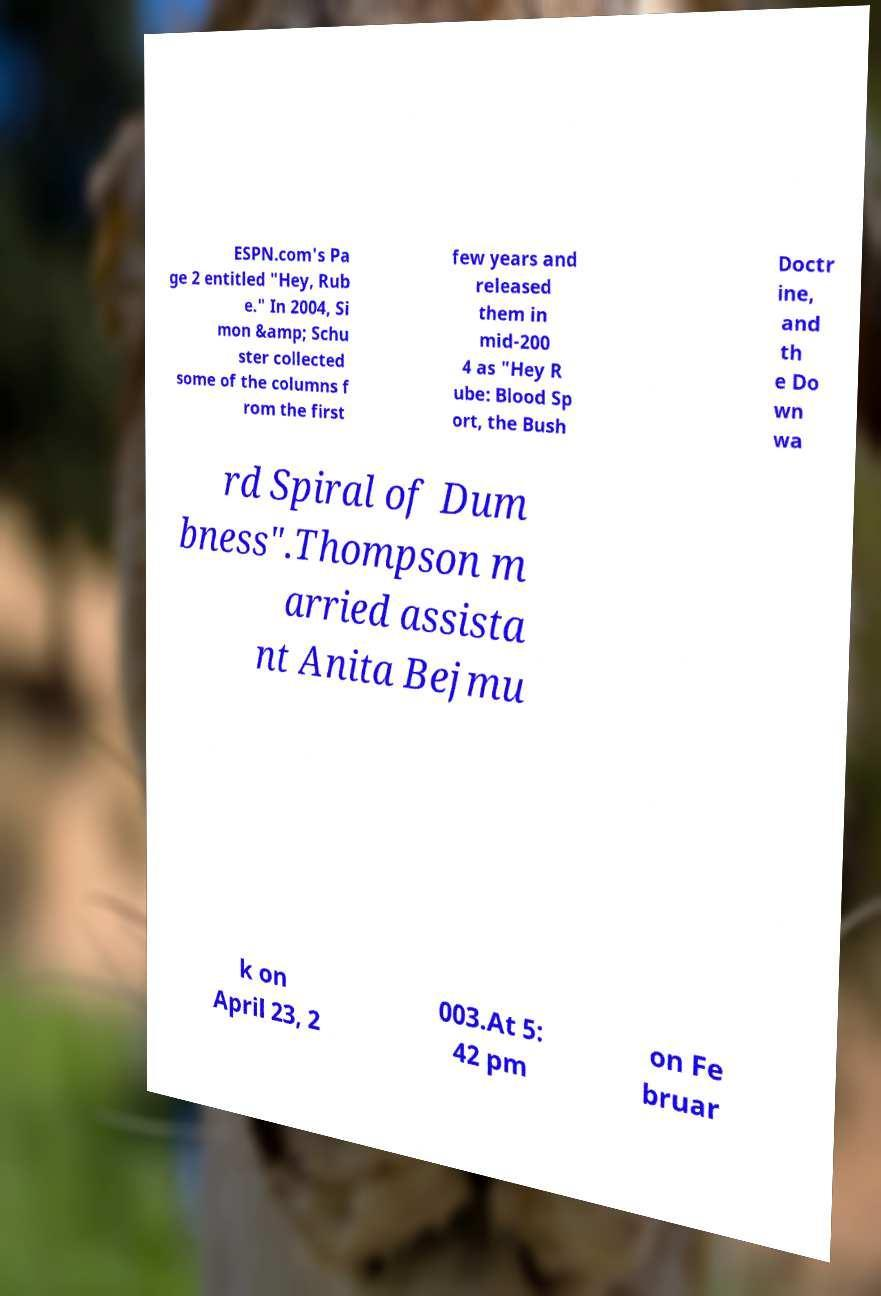Please read and relay the text visible in this image. What does it say? ESPN.com's Pa ge 2 entitled "Hey, Rub e." In 2004, Si mon &amp; Schu ster collected some of the columns f rom the first few years and released them in mid-200 4 as "Hey R ube: Blood Sp ort, the Bush Doctr ine, and th e Do wn wa rd Spiral of Dum bness".Thompson m arried assista nt Anita Bejmu k on April 23, 2 003.At 5: 42 pm on Fe bruar 